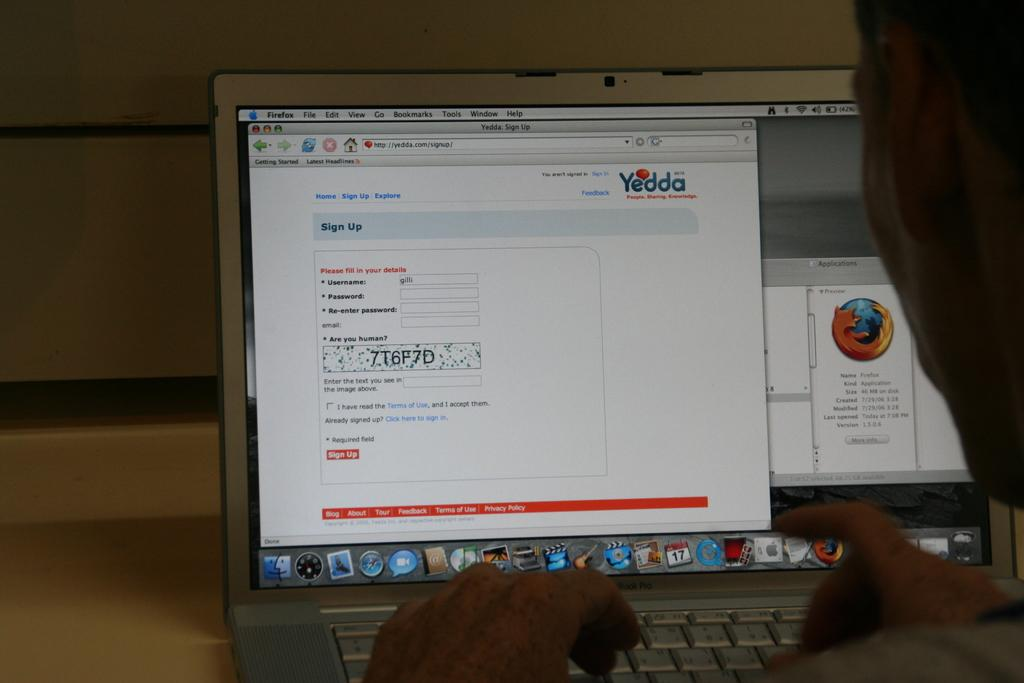<image>
Provide a brief description of the given image. The Yedda website requires the user to enter their username and password. 